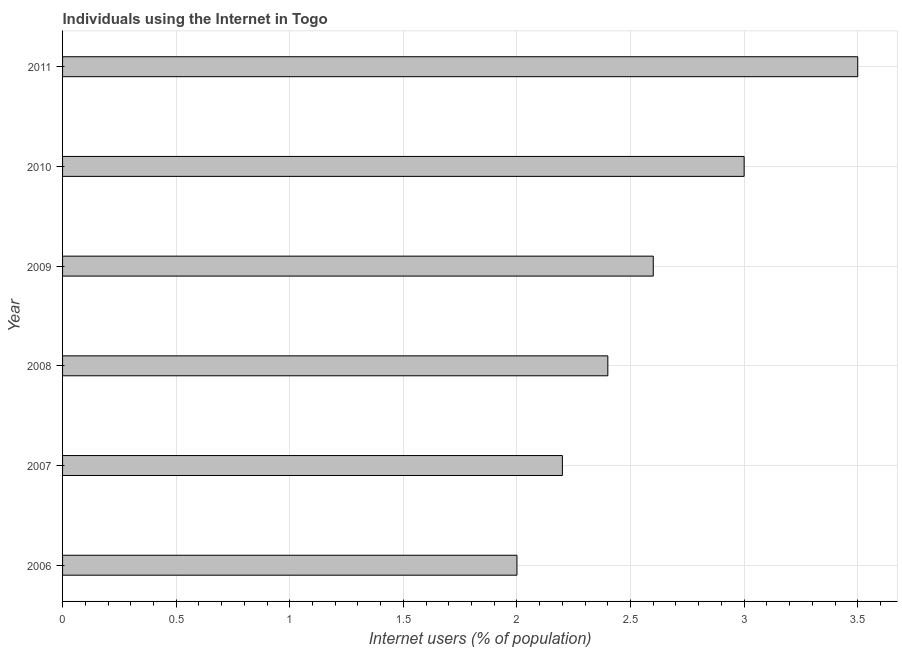Does the graph contain grids?
Your response must be concise. Yes. What is the title of the graph?
Provide a short and direct response. Individuals using the Internet in Togo. What is the label or title of the X-axis?
Offer a very short reply. Internet users (% of population). What is the label or title of the Y-axis?
Your answer should be very brief. Year. Across all years, what is the maximum number of internet users?
Offer a terse response. 3.5. Across all years, what is the minimum number of internet users?
Ensure brevity in your answer.  2. In which year was the number of internet users maximum?
Keep it short and to the point. 2011. In which year was the number of internet users minimum?
Make the answer very short. 2006. What is the sum of the number of internet users?
Your answer should be very brief. 15.7. What is the difference between the number of internet users in 2007 and 2008?
Your answer should be very brief. -0.2. What is the average number of internet users per year?
Make the answer very short. 2.62. What is the median number of internet users?
Keep it short and to the point. 2.5. What is the ratio of the number of internet users in 2009 to that in 2011?
Provide a short and direct response. 0.74. Is the difference between the number of internet users in 2009 and 2011 greater than the difference between any two years?
Offer a terse response. No. What is the difference between the highest and the second highest number of internet users?
Your answer should be compact. 0.5. Is the sum of the number of internet users in 2008 and 2011 greater than the maximum number of internet users across all years?
Make the answer very short. Yes. How many years are there in the graph?
Your answer should be very brief. 6. What is the difference between two consecutive major ticks on the X-axis?
Your response must be concise. 0.5. Are the values on the major ticks of X-axis written in scientific E-notation?
Your answer should be very brief. No. What is the Internet users (% of population) of 2008?
Offer a very short reply. 2.4. What is the Internet users (% of population) of 2009?
Provide a short and direct response. 2.6. What is the Internet users (% of population) of 2010?
Your response must be concise. 3. What is the Internet users (% of population) of 2011?
Make the answer very short. 3.5. What is the difference between the Internet users (% of population) in 2006 and 2008?
Your answer should be very brief. -0.4. What is the difference between the Internet users (% of population) in 2006 and 2010?
Offer a terse response. -1. What is the difference between the Internet users (% of population) in 2006 and 2011?
Make the answer very short. -1.5. What is the difference between the Internet users (% of population) in 2007 and 2009?
Offer a very short reply. -0.4. What is the difference between the Internet users (% of population) in 2007 and 2011?
Give a very brief answer. -1.3. What is the difference between the Internet users (% of population) in 2008 and 2009?
Your response must be concise. -0.2. What is the difference between the Internet users (% of population) in 2008 and 2011?
Provide a succinct answer. -1.1. What is the difference between the Internet users (% of population) in 2009 and 2010?
Offer a terse response. -0.4. What is the difference between the Internet users (% of population) in 2009 and 2011?
Give a very brief answer. -0.9. What is the difference between the Internet users (% of population) in 2010 and 2011?
Your response must be concise. -0.5. What is the ratio of the Internet users (% of population) in 2006 to that in 2007?
Ensure brevity in your answer.  0.91. What is the ratio of the Internet users (% of population) in 2006 to that in 2008?
Keep it short and to the point. 0.83. What is the ratio of the Internet users (% of population) in 2006 to that in 2009?
Offer a terse response. 0.77. What is the ratio of the Internet users (% of population) in 2006 to that in 2010?
Provide a succinct answer. 0.67. What is the ratio of the Internet users (% of population) in 2006 to that in 2011?
Provide a succinct answer. 0.57. What is the ratio of the Internet users (% of population) in 2007 to that in 2008?
Make the answer very short. 0.92. What is the ratio of the Internet users (% of population) in 2007 to that in 2009?
Your answer should be very brief. 0.85. What is the ratio of the Internet users (% of population) in 2007 to that in 2010?
Keep it short and to the point. 0.73. What is the ratio of the Internet users (% of population) in 2007 to that in 2011?
Your answer should be compact. 0.63. What is the ratio of the Internet users (% of population) in 2008 to that in 2009?
Make the answer very short. 0.92. What is the ratio of the Internet users (% of population) in 2008 to that in 2010?
Offer a very short reply. 0.8. What is the ratio of the Internet users (% of population) in 2008 to that in 2011?
Make the answer very short. 0.69. What is the ratio of the Internet users (% of population) in 2009 to that in 2010?
Keep it short and to the point. 0.87. What is the ratio of the Internet users (% of population) in 2009 to that in 2011?
Your response must be concise. 0.74. What is the ratio of the Internet users (% of population) in 2010 to that in 2011?
Keep it short and to the point. 0.86. 